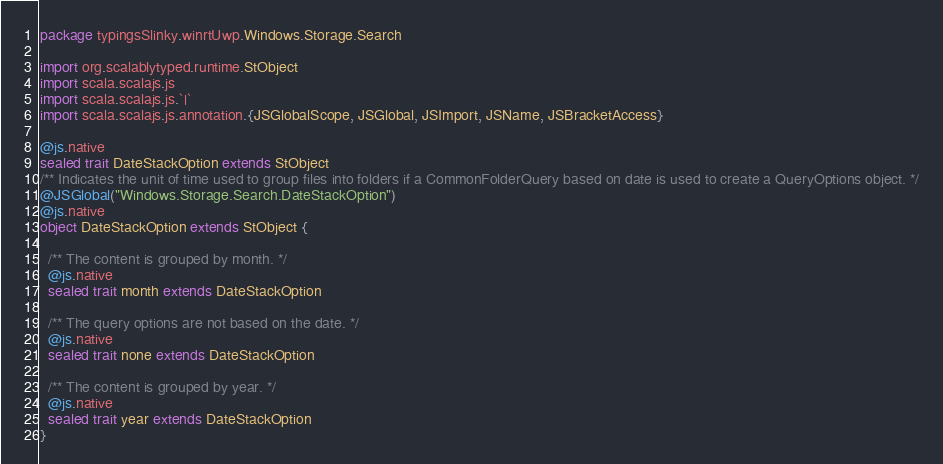Convert code to text. <code><loc_0><loc_0><loc_500><loc_500><_Scala_>package typingsSlinky.winrtUwp.Windows.Storage.Search

import org.scalablytyped.runtime.StObject
import scala.scalajs.js
import scala.scalajs.js.`|`
import scala.scalajs.js.annotation.{JSGlobalScope, JSGlobal, JSImport, JSName, JSBracketAccess}

@js.native
sealed trait DateStackOption extends StObject
/** Indicates the unit of time used to group files into folders if a CommonFolderQuery based on date is used to create a QueryOptions object. */
@JSGlobal("Windows.Storage.Search.DateStackOption")
@js.native
object DateStackOption extends StObject {
  
  /** The content is grouped by month. */
  @js.native
  sealed trait month extends DateStackOption
  
  /** The query options are not based on the date. */
  @js.native
  sealed trait none extends DateStackOption
  
  /** The content is grouped by year. */
  @js.native
  sealed trait year extends DateStackOption
}
</code> 